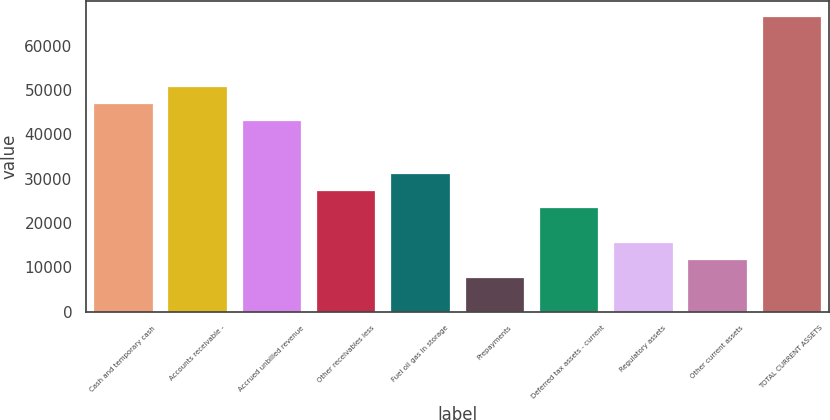Convert chart to OTSL. <chart><loc_0><loc_0><loc_500><loc_500><bar_chart><fcel>Cash and temporary cash<fcel>Accounts receivable -<fcel>Accrued unbilled revenue<fcel>Other receivables less<fcel>Fuel oil gas in storage<fcel>Prepayments<fcel>Deferred tax assets - current<fcel>Regulatory assets<fcel>Other current assets<fcel>TOTAL CURRENT ASSETS<nl><fcel>47056.2<fcel>50977.3<fcel>43135.1<fcel>27450.7<fcel>31371.8<fcel>7845.2<fcel>23529.6<fcel>15687.4<fcel>11766.3<fcel>66661.7<nl></chart> 